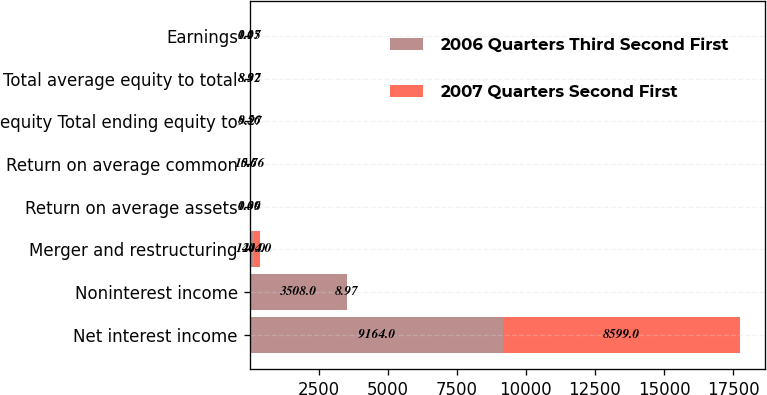Convert chart to OTSL. <chart><loc_0><loc_0><loc_500><loc_500><stacked_bar_chart><ecel><fcel>Net interest income<fcel>Noninterest income<fcel>Merger and restructuring<fcel>Return on average assets<fcel>Return on average common<fcel>equity Total ending equity to<fcel>Total average equity to total<fcel>Earnings<nl><fcel>2006 Quarters Third Second First<fcel>9164<fcel>3508<fcel>140<fcel>0.06<fcel>0.6<fcel>8.56<fcel>8.32<fcel>0.05<nl><fcel>2007 Quarters Second First<fcel>8599<fcel>8.97<fcel>244<fcel>1.39<fcel>15.76<fcel>9.27<fcel>8.97<fcel>1.17<nl></chart> 